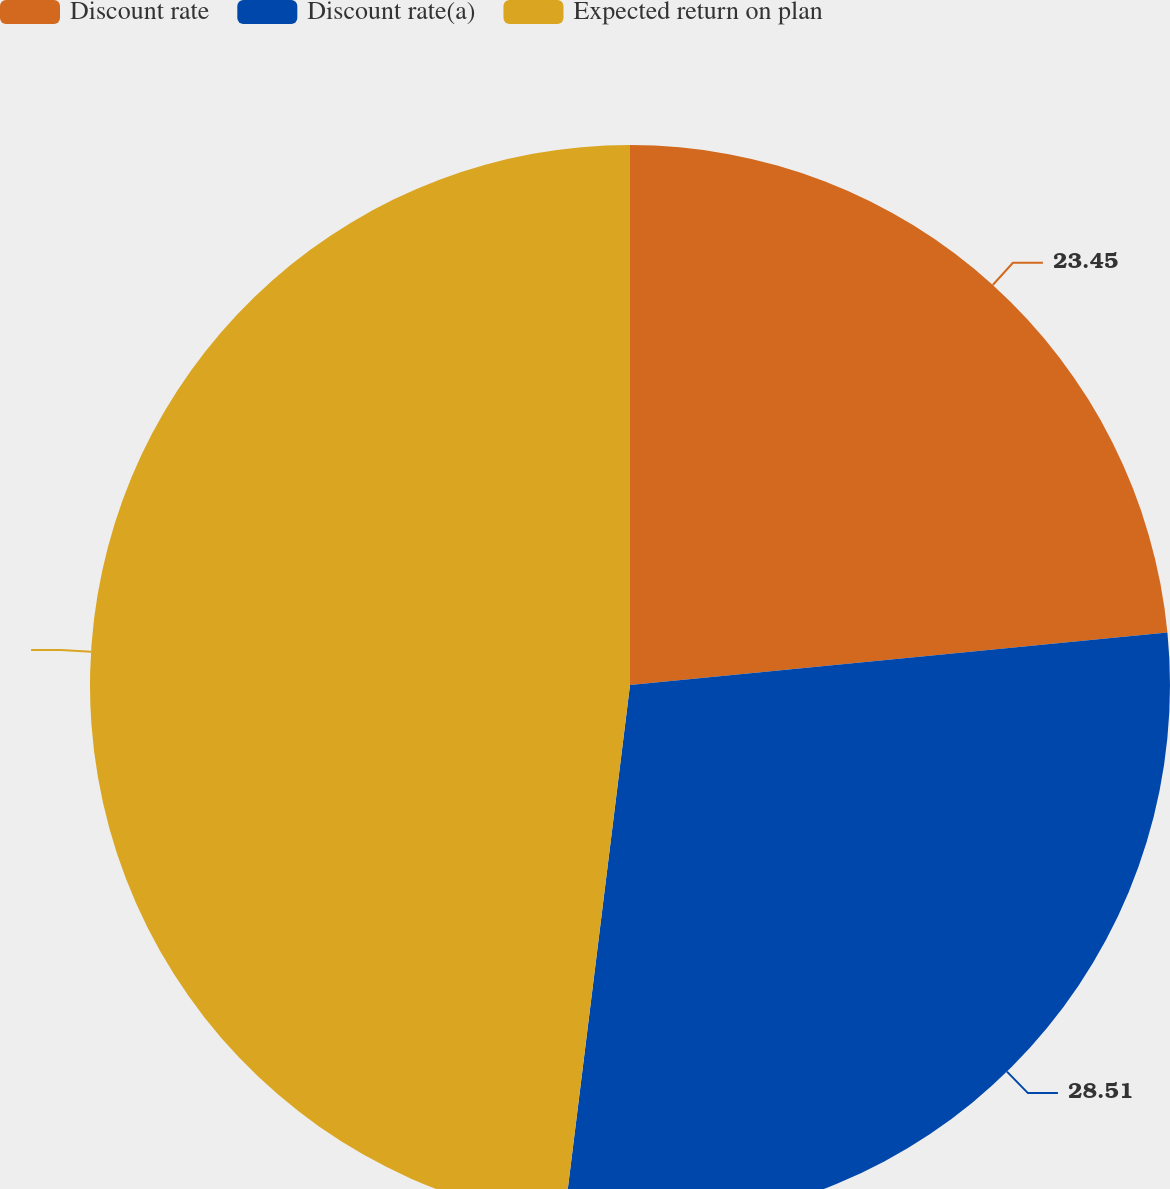Convert chart. <chart><loc_0><loc_0><loc_500><loc_500><pie_chart><fcel>Discount rate<fcel>Discount rate(a)<fcel>Expected return on plan<nl><fcel>23.45%<fcel>28.51%<fcel>48.05%<nl></chart> 